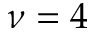Convert formula to latex. <formula><loc_0><loc_0><loc_500><loc_500>\nu = 4</formula> 